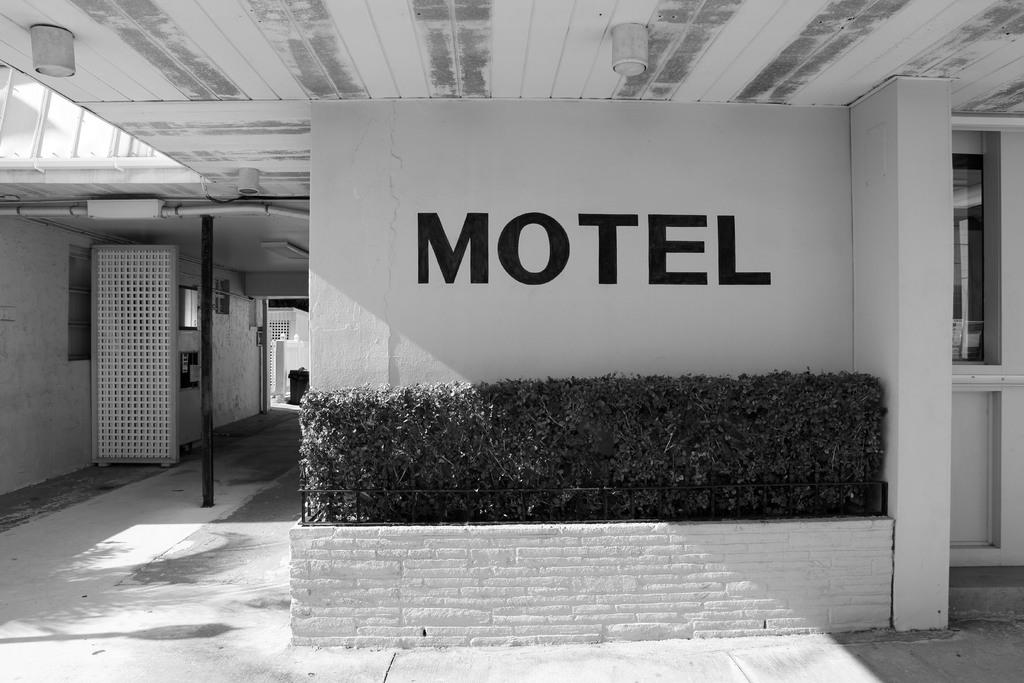What type of structure is visible in the image? There is a house in the image. What other elements can be seen in the image besides the house? There are plants and lights visible in the image. Is there any text present in the image? Yes, there is text on a wall in the image. Can you see any rabbits in the image? There are no rabbits present in the image. What type of animals might be found at the zoo in the image? There is no zoo present in the image, so it is not possible to determine what type of animals might be found there. 